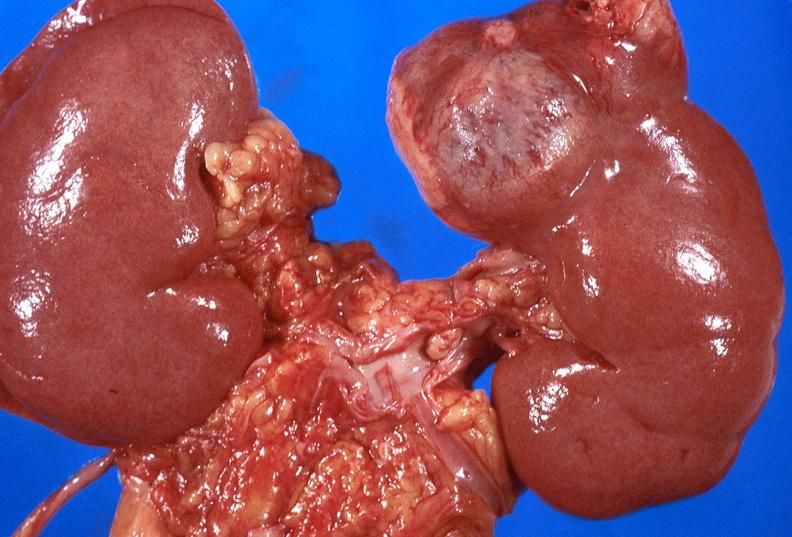where is this?
Answer the question using a single word or phrase. Urinary 